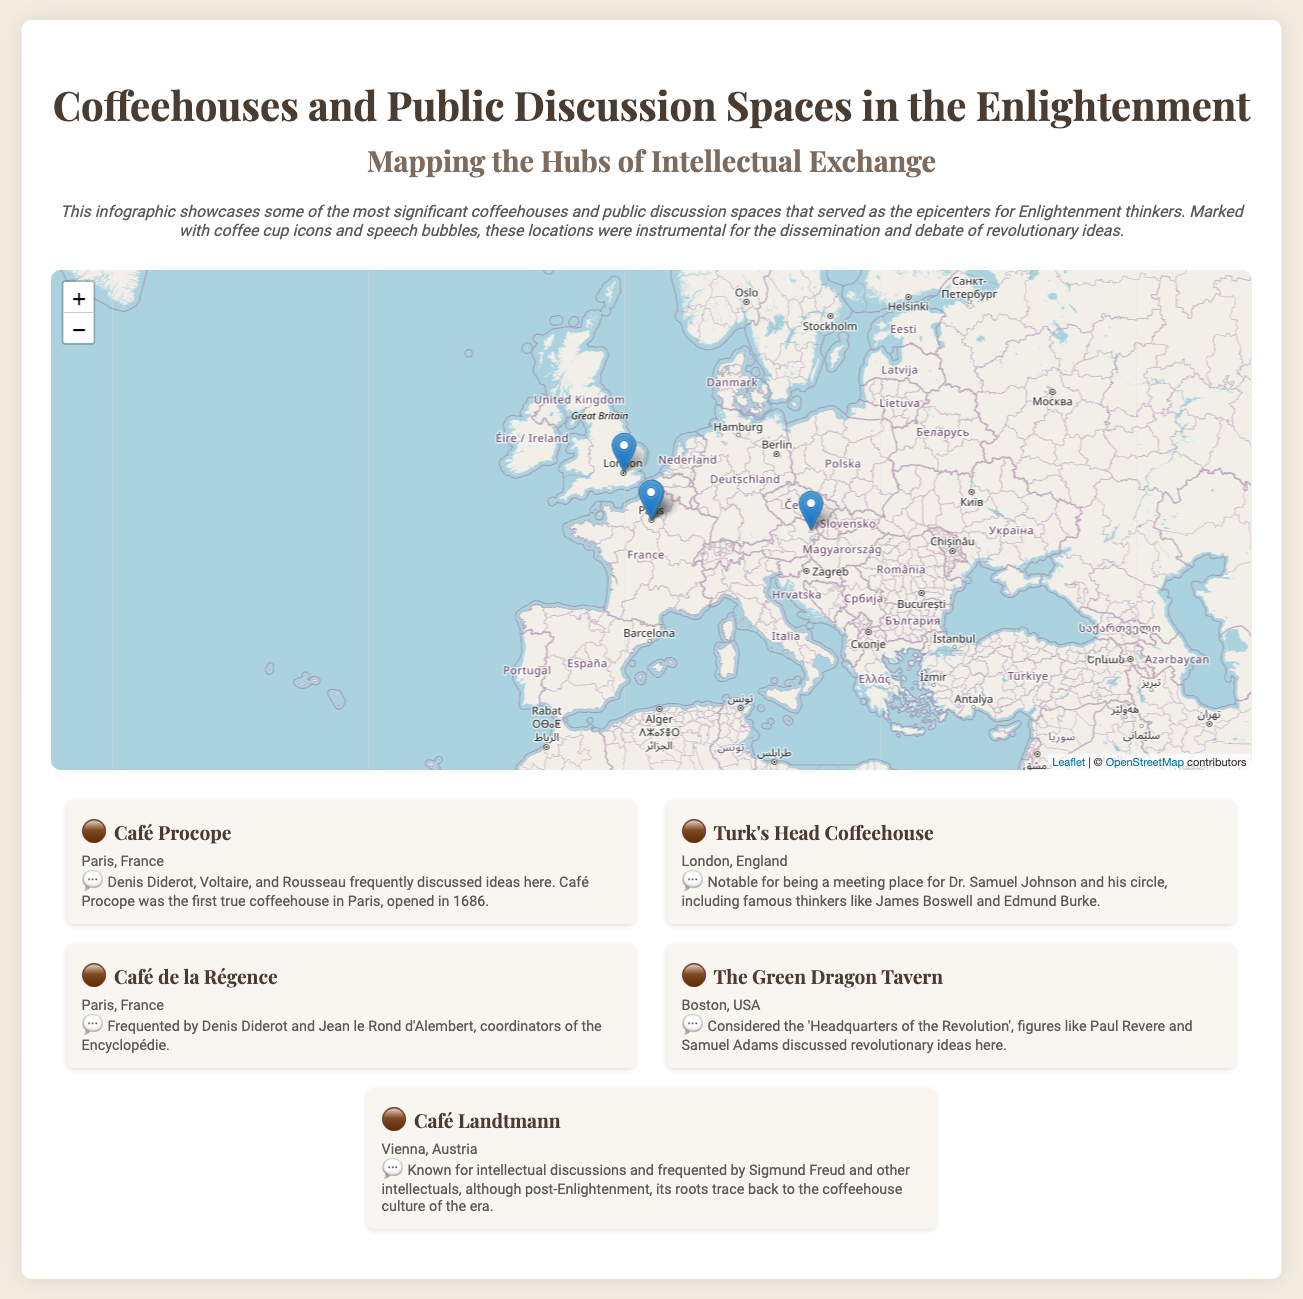What is the name of the first true coffeehouse in Paris? The first true coffeehouse in Paris is identified in the document as Café Procope, which opened in 1686.
Answer: Café Procope Which thinker frequently visited Café de la Régence? The document notes that Denis Diderot and Jean le Rond d'Alembert frequented Café de la Régence, where they coordinated the Encyclopédie.
Answer: Denis Diderot In which city is The Green Dragon Tavern located? The Green Dragon Tavern is mentioned as being in Boston, USA in the document.
Answer: Boston Who is noted for discussing revolutionary ideas at The Green Dragon Tavern? The document states that figures like Paul Revere and Samuel Adams discussed revolutionary ideas at The Green Dragon Tavern.
Answer: Paul Revere What year was Café Procope opened? According to the document, Café Procope opened in 1686, marking it as a significant coffeehouse during the Enlightenment.
Answer: 1686 What is the geographical coordinate system used to denote locations in the map? The map includes latitude and longitude coordinates to specify the locations of the coffeehouses and discussion spaces.
Answer: Latitude and longitude Which intellectuals frequented Café Landtmann, mentioned in the document? The document highlights that Café Landtmann was frequented by Sigmund Freud and other intellectuals, emphasizing its importance in intellectual discussions.
Answer: Sigmund Freud Which coffeehouse served as the "Headquarters of the Revolution"? The document describes The Green Dragon Tavern as considered the 'Headquarters of the Revolution'.
Answer: The Green Dragon Tavern What type of visual markers are used in the map for these significant spots? The document specifies that coffee cup icons and speech bubbles are used to mark important locations on the map.
Answer: Coffee cup icons and speech bubbles 